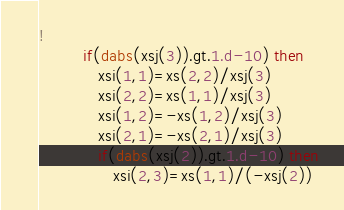<code> <loc_0><loc_0><loc_500><loc_500><_FORTRAN_>!     
         if(dabs(xsj(3)).gt.1.d-10) then
            xsi(1,1)=xs(2,2)/xsj(3)
            xsi(2,2)=xs(1,1)/xsj(3)
            xsi(1,2)=-xs(1,2)/xsj(3)
            xsi(2,1)=-xs(2,1)/xsj(3)
            if(dabs(xsj(2)).gt.1.d-10) then
               xsi(2,3)=xs(1,1)/(-xsj(2))</code> 